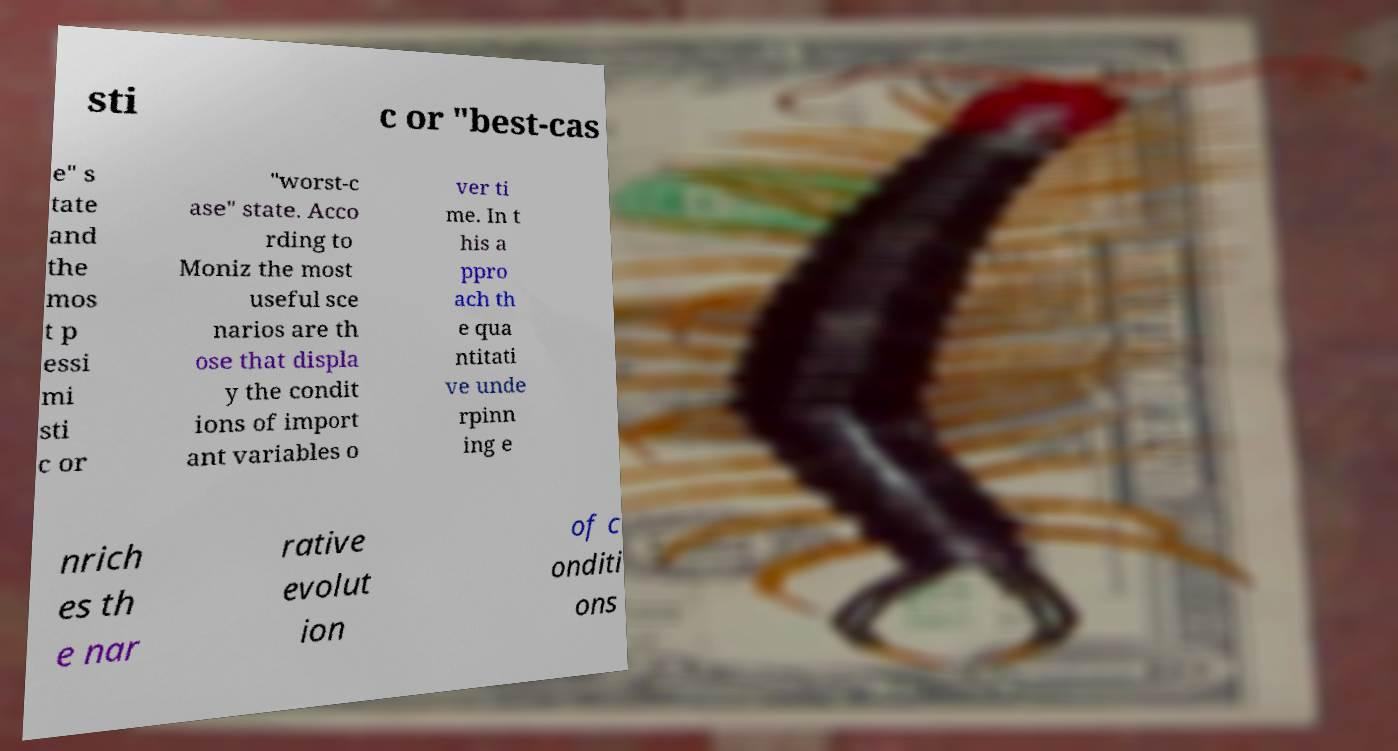For documentation purposes, I need the text within this image transcribed. Could you provide that? sti c or "best-cas e" s tate and the mos t p essi mi sti c or "worst-c ase" state. Acco rding to Moniz the most useful sce narios are th ose that displa y the condit ions of import ant variables o ver ti me. In t his a ppro ach th e qua ntitati ve unde rpinn ing e nrich es th e nar rative evolut ion of c onditi ons 